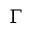Convert formula to latex. <formula><loc_0><loc_0><loc_500><loc_500>\Gamma</formula> 